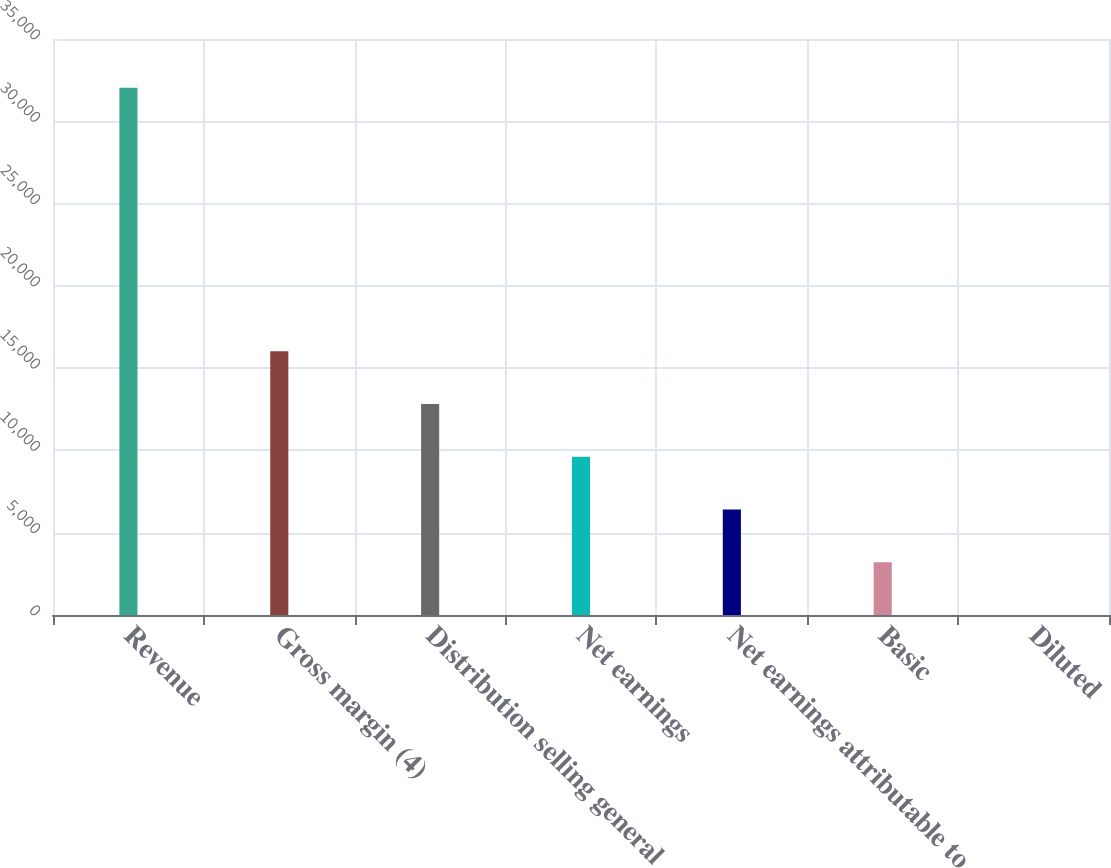<chart> <loc_0><loc_0><loc_500><loc_500><bar_chart><fcel>Revenue<fcel>Gross margin (4)<fcel>Distribution selling general<fcel>Net earnings<fcel>Net earnings attributable to<fcel>Basic<fcel>Diluted<nl><fcel>32039<fcel>16020<fcel>12816.2<fcel>9612.36<fcel>6408.56<fcel>3204.76<fcel>0.96<nl></chart> 